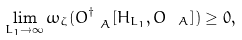Convert formula to latex. <formula><loc_0><loc_0><loc_500><loc_500>\lim _ { L _ { 1 } \rightarrow \infty } \omega _ { \zeta } ( O _ { \ A } ^ { \dagger } [ H _ { L _ { 1 } } , O _ { \ A } ] ) \geq 0 ,</formula> 